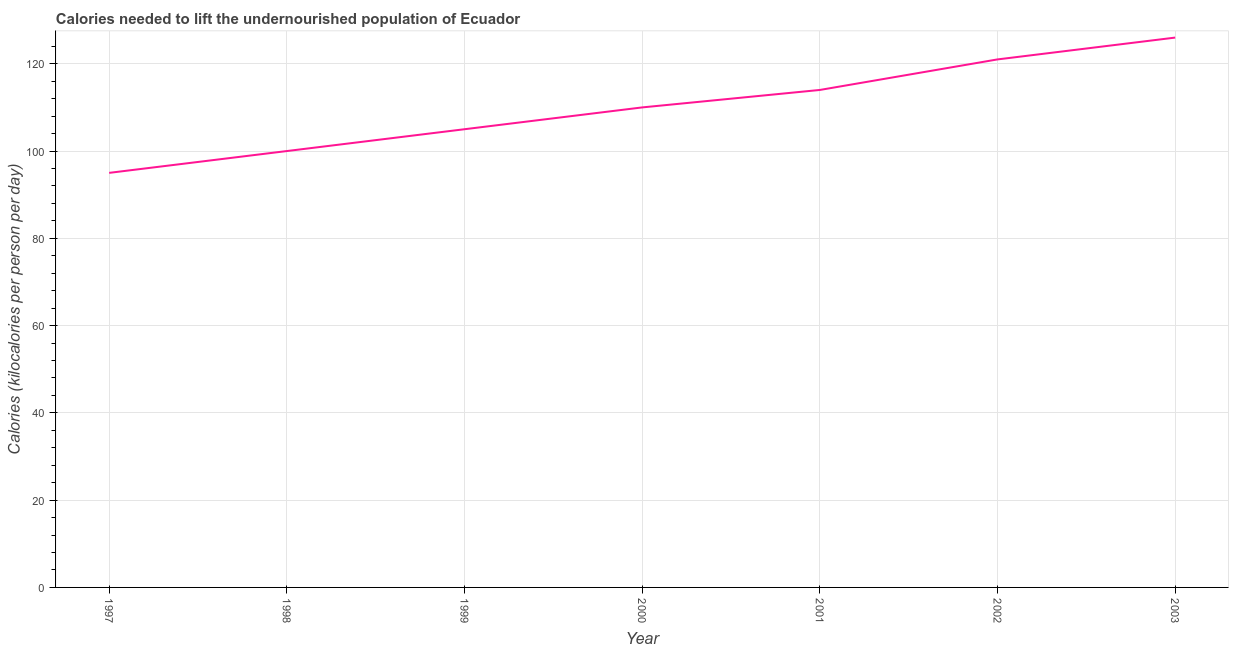What is the depth of food deficit in 2000?
Your response must be concise. 110. Across all years, what is the maximum depth of food deficit?
Make the answer very short. 126. Across all years, what is the minimum depth of food deficit?
Provide a short and direct response. 95. In which year was the depth of food deficit minimum?
Your answer should be compact. 1997. What is the sum of the depth of food deficit?
Ensure brevity in your answer.  771. What is the difference between the depth of food deficit in 2000 and 2003?
Ensure brevity in your answer.  -16. What is the average depth of food deficit per year?
Offer a very short reply. 110.14. What is the median depth of food deficit?
Offer a terse response. 110. What is the ratio of the depth of food deficit in 1998 to that in 2001?
Your answer should be compact. 0.88. Is the depth of food deficit in 1997 less than that in 2001?
Provide a short and direct response. Yes. What is the difference between the highest and the second highest depth of food deficit?
Provide a short and direct response. 5. Is the sum of the depth of food deficit in 2000 and 2001 greater than the maximum depth of food deficit across all years?
Your answer should be very brief. Yes. What is the difference between the highest and the lowest depth of food deficit?
Provide a short and direct response. 31. In how many years, is the depth of food deficit greater than the average depth of food deficit taken over all years?
Your answer should be compact. 3. How many lines are there?
Keep it short and to the point. 1. What is the difference between two consecutive major ticks on the Y-axis?
Offer a terse response. 20. Does the graph contain any zero values?
Your answer should be very brief. No. Does the graph contain grids?
Provide a succinct answer. Yes. What is the title of the graph?
Your answer should be very brief. Calories needed to lift the undernourished population of Ecuador. What is the label or title of the X-axis?
Provide a succinct answer. Year. What is the label or title of the Y-axis?
Your answer should be compact. Calories (kilocalories per person per day). What is the Calories (kilocalories per person per day) of 1997?
Your answer should be very brief. 95. What is the Calories (kilocalories per person per day) of 1999?
Give a very brief answer. 105. What is the Calories (kilocalories per person per day) in 2000?
Your answer should be compact. 110. What is the Calories (kilocalories per person per day) in 2001?
Give a very brief answer. 114. What is the Calories (kilocalories per person per day) in 2002?
Offer a very short reply. 121. What is the Calories (kilocalories per person per day) in 2003?
Make the answer very short. 126. What is the difference between the Calories (kilocalories per person per day) in 1997 and 1998?
Provide a short and direct response. -5. What is the difference between the Calories (kilocalories per person per day) in 1997 and 2000?
Provide a succinct answer. -15. What is the difference between the Calories (kilocalories per person per day) in 1997 and 2002?
Ensure brevity in your answer.  -26. What is the difference between the Calories (kilocalories per person per day) in 1997 and 2003?
Provide a succinct answer. -31. What is the difference between the Calories (kilocalories per person per day) in 1998 and 1999?
Provide a succinct answer. -5. What is the difference between the Calories (kilocalories per person per day) in 1998 and 2000?
Offer a terse response. -10. What is the difference between the Calories (kilocalories per person per day) in 1998 and 2001?
Provide a succinct answer. -14. What is the difference between the Calories (kilocalories per person per day) in 1998 and 2003?
Make the answer very short. -26. What is the difference between the Calories (kilocalories per person per day) in 1999 and 2000?
Your answer should be compact. -5. What is the difference between the Calories (kilocalories per person per day) in 1999 and 2001?
Your answer should be very brief. -9. What is the difference between the Calories (kilocalories per person per day) in 1999 and 2002?
Make the answer very short. -16. What is the difference between the Calories (kilocalories per person per day) in 2000 and 2002?
Offer a terse response. -11. What is the difference between the Calories (kilocalories per person per day) in 2000 and 2003?
Keep it short and to the point. -16. What is the difference between the Calories (kilocalories per person per day) in 2001 and 2002?
Your answer should be compact. -7. What is the difference between the Calories (kilocalories per person per day) in 2001 and 2003?
Provide a short and direct response. -12. What is the difference between the Calories (kilocalories per person per day) in 2002 and 2003?
Offer a terse response. -5. What is the ratio of the Calories (kilocalories per person per day) in 1997 to that in 1999?
Ensure brevity in your answer.  0.91. What is the ratio of the Calories (kilocalories per person per day) in 1997 to that in 2000?
Offer a very short reply. 0.86. What is the ratio of the Calories (kilocalories per person per day) in 1997 to that in 2001?
Offer a very short reply. 0.83. What is the ratio of the Calories (kilocalories per person per day) in 1997 to that in 2002?
Make the answer very short. 0.79. What is the ratio of the Calories (kilocalories per person per day) in 1997 to that in 2003?
Offer a very short reply. 0.75. What is the ratio of the Calories (kilocalories per person per day) in 1998 to that in 2000?
Make the answer very short. 0.91. What is the ratio of the Calories (kilocalories per person per day) in 1998 to that in 2001?
Your answer should be compact. 0.88. What is the ratio of the Calories (kilocalories per person per day) in 1998 to that in 2002?
Offer a terse response. 0.83. What is the ratio of the Calories (kilocalories per person per day) in 1998 to that in 2003?
Make the answer very short. 0.79. What is the ratio of the Calories (kilocalories per person per day) in 1999 to that in 2000?
Your answer should be very brief. 0.95. What is the ratio of the Calories (kilocalories per person per day) in 1999 to that in 2001?
Give a very brief answer. 0.92. What is the ratio of the Calories (kilocalories per person per day) in 1999 to that in 2002?
Offer a terse response. 0.87. What is the ratio of the Calories (kilocalories per person per day) in 1999 to that in 2003?
Give a very brief answer. 0.83. What is the ratio of the Calories (kilocalories per person per day) in 2000 to that in 2001?
Your answer should be very brief. 0.96. What is the ratio of the Calories (kilocalories per person per day) in 2000 to that in 2002?
Ensure brevity in your answer.  0.91. What is the ratio of the Calories (kilocalories per person per day) in 2000 to that in 2003?
Give a very brief answer. 0.87. What is the ratio of the Calories (kilocalories per person per day) in 2001 to that in 2002?
Provide a succinct answer. 0.94. What is the ratio of the Calories (kilocalories per person per day) in 2001 to that in 2003?
Keep it short and to the point. 0.91. 